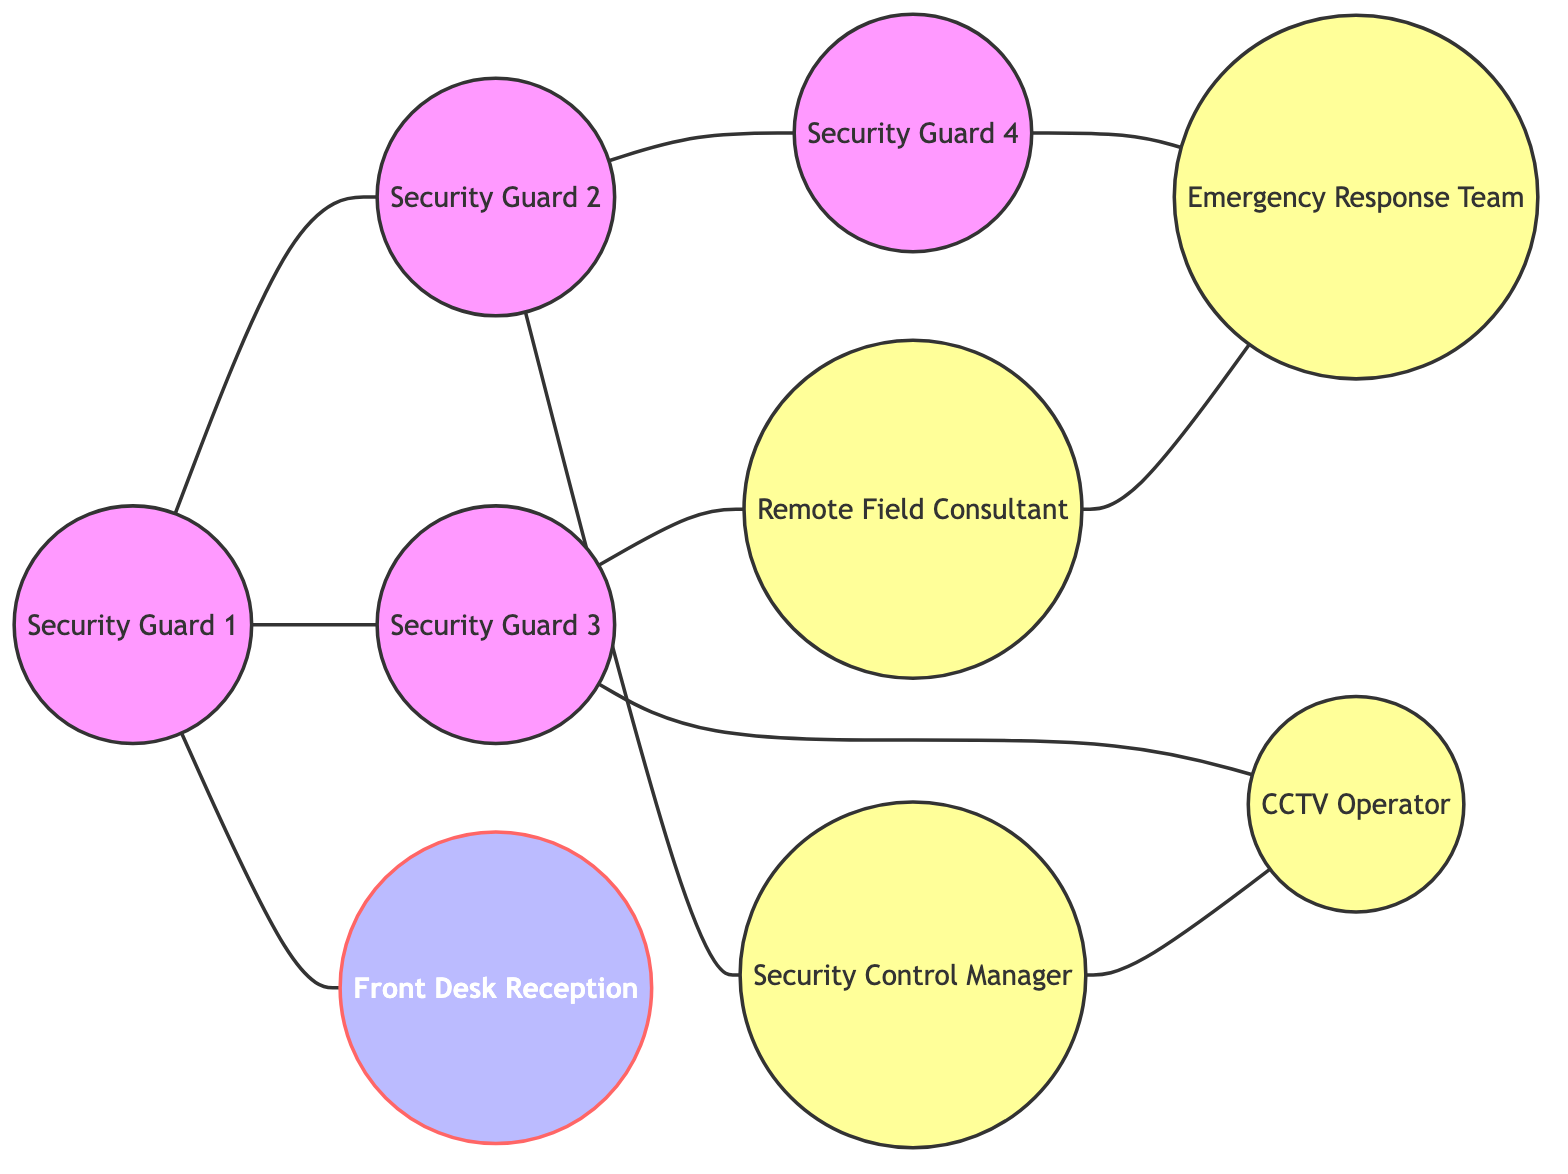What is the total number of nodes in the diagram? The diagram lists the total nodes as Security Guard 1, Security Guard 2, Security Guard 3, Security Guard 4, Security Control Manager, Remote Field Consultant, CCTV Operator, Emergency Response Team, and Front Desk Reception. Counting these, there are 9 nodes in total.
Answer: 9 Which security guard is directly connected to the Front Desk Reception? Looking at the diagram, Security Guard 1 has a direct connection to the Front Desk Reception with an edge.
Answer: Security Guard 1 How many edges are there in total connecting the members? The diagram shows connections (edges) among the members. By counting each relationship listed in the edges section, there are a total of 10 edges.
Answer: 10 Which security guard has a connection with the Emergency Response Team? Review the edges: Security Guard 4 is shown with an edge connected to the Emergency Response Team.
Answer: Security Guard 4 What is the link between the Security Control Manager and the CCTV Operator? Observing the edges, there is a direct connection (edge) between the Security Control Manager and the CCTV Operator.
Answer: Direct connection How many connections does Security Guard 2 have? Security Guard 2 is linked to Security Guard 1, Security Guard 4, and the Security Control Manager. Counting these connections, Security Guard 2 has a total of 3 connections.
Answer: 3 Who is connected to the Remote Field Consultant? The edges indicate that Security Guard 3 and the Emergency Response Team are connected to the Remote Field Consultant. Summing these, the Remote Field Consultant has 2 connections.
Answer: Security Guard 3 and Emergency Response Team What type of node is the Front Desk Reception categorized as? In the diagram, the Front Desk Reception is labeled as a manager based on the class definitions.
Answer: Manager Which security personnel has the most connections? By analyzing the edges, Security Guard 1 connects to Security Guard 2, Security Guard 3, and the Front Desk Reception, making a total of 3 connections. Thus, Security Guard 1 has the most connections as compared to others as no one has more than 3.
Answer: Security Guard 1 